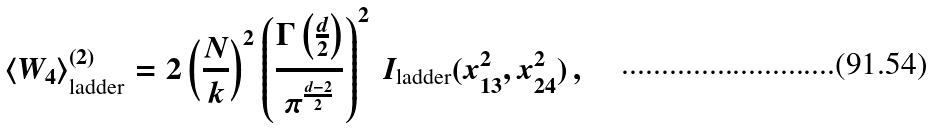Convert formula to latex. <formula><loc_0><loc_0><loc_500><loc_500>\langle W _ { 4 } \rangle ^ { ( 2 ) } _ { \text {ladder} } & = 2 \left ( \frac { N } { k } \right ) ^ { 2 } \left ( \frac { \Gamma \left ( \frac { d } { 2 } \right ) } { \pi ^ { \frac { d - 2 } { 2 } } } \right ) ^ { 2 } \, I _ { \text {ladder} } ( x _ { 1 3 } ^ { 2 } , x _ { 2 4 } ^ { 2 } ) \, ,</formula> 